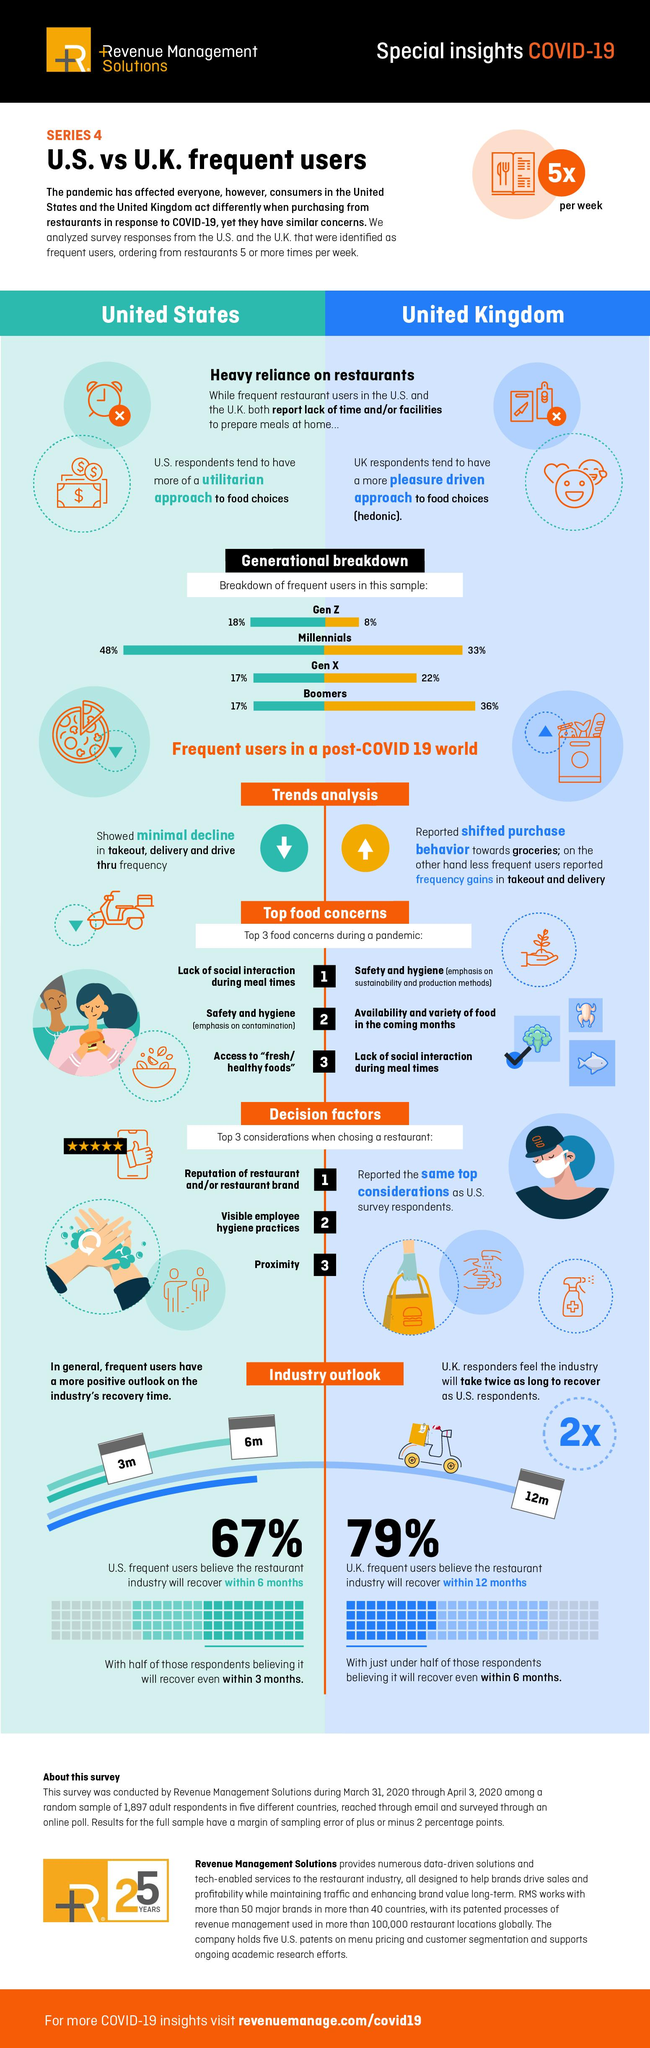Draw attention to some important aspects in this diagram. The respondents in the UK reported an increase in the use of takeout and delivery services. The respondents who showed minimal decline in food buying trends were identified as US. Seventy-nine percent of UK responders believe that the industry will recover and bounce back within a year. 48% of the US respondents belong to the Millennial generation. The third major food concern among US respondents was access to fresh and healthy foods. 